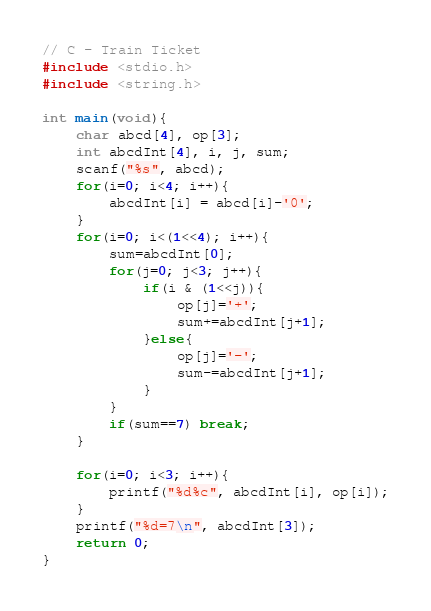Convert code to text. <code><loc_0><loc_0><loc_500><loc_500><_C_>// C - Train Ticket
#include <stdio.h>
#include <string.h>

int main(void){
    char abcd[4], op[3];
    int abcdInt[4], i, j, sum;
    scanf("%s", abcd);
    for(i=0; i<4; i++){
        abcdInt[i] = abcd[i]-'0';
    }
    for(i=0; i<(1<<4); i++){
        sum=abcdInt[0];
        for(j=0; j<3; j++){
            if(i & (1<<j)){
                op[j]='+';
                sum+=abcdInt[j+1];
            }else{
                op[j]='-';
                sum-=abcdInt[j+1];
            }
        }
        if(sum==7) break;
    }

    for(i=0; i<3; i++){
        printf("%d%c", abcdInt[i], op[i]);
    }
    printf("%d=7\n", abcdInt[3]);
    return 0;
}
</code> 